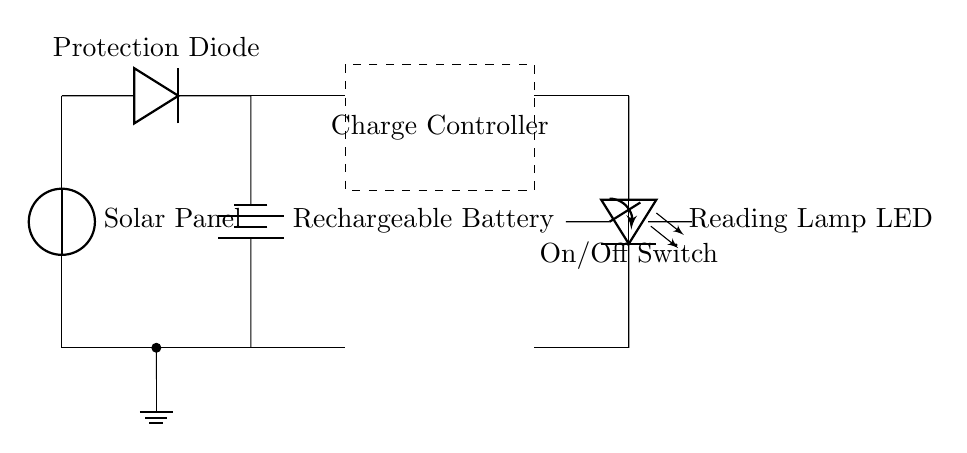What is the main function of the solar panel? The primary role of the solar panel in this circuit is to convert sunlight into electrical energy, which is then used to charge the battery.
Answer: convert sunlight What component prevents reverse current flow? The protection diode is crucial as it allows current to flow only in one direction, preventing any backflow that could damage the solar panel or battery.
Answer: protection diode What type of battery is used in this circuit? A rechargeable battery is specified, designed to store the energy collected from the solar panel for later use when the lamp is needed.
Answer: rechargeable battery What does the charge controller do? The charge controller manages the flow of electricity from the solar panel to the battery, ensuring safe charging and preventing overcharging or depletion.
Answer: manages charging How many LEDs are in the circuit? The circuit diagram indicates a single LED, which serves as the reading lamp being powered by the stored solar energy.
Answer: one LED What is the need for an On/Off switch in this circuit? The On/Off switch allows users to control whether the reading lamp is activated or deactivated, providing convenience and battery conservation.
Answer: user control Which component discharges energy to the reading lamp? The LED discharges energy to provide light for reading when the circuit is completed with the switch in the "On" position.
Answer: LED 